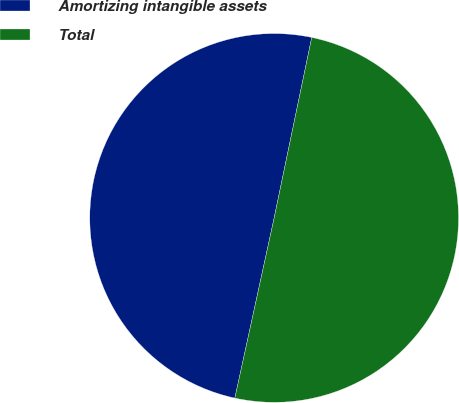Convert chart to OTSL. <chart><loc_0><loc_0><loc_500><loc_500><pie_chart><fcel>Amortizing intangible assets<fcel>Total<nl><fcel>49.85%<fcel>50.15%<nl></chart> 